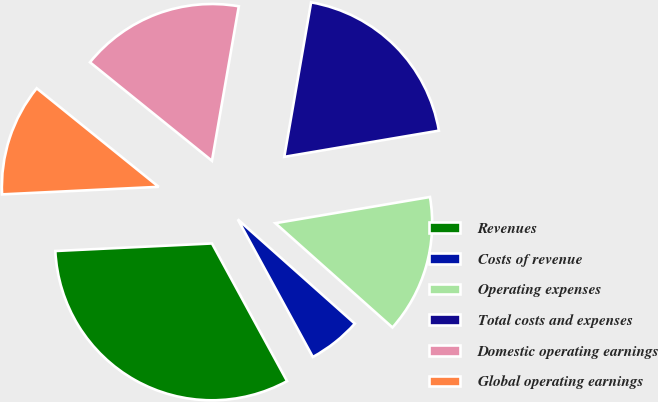<chart> <loc_0><loc_0><loc_500><loc_500><pie_chart><fcel>Revenues<fcel>Costs of revenue<fcel>Operating expenses<fcel>Total costs and expenses<fcel>Domestic operating earnings<fcel>Global operating earnings<nl><fcel>32.18%<fcel>5.47%<fcel>14.25%<fcel>19.59%<fcel>16.92%<fcel>11.58%<nl></chart> 